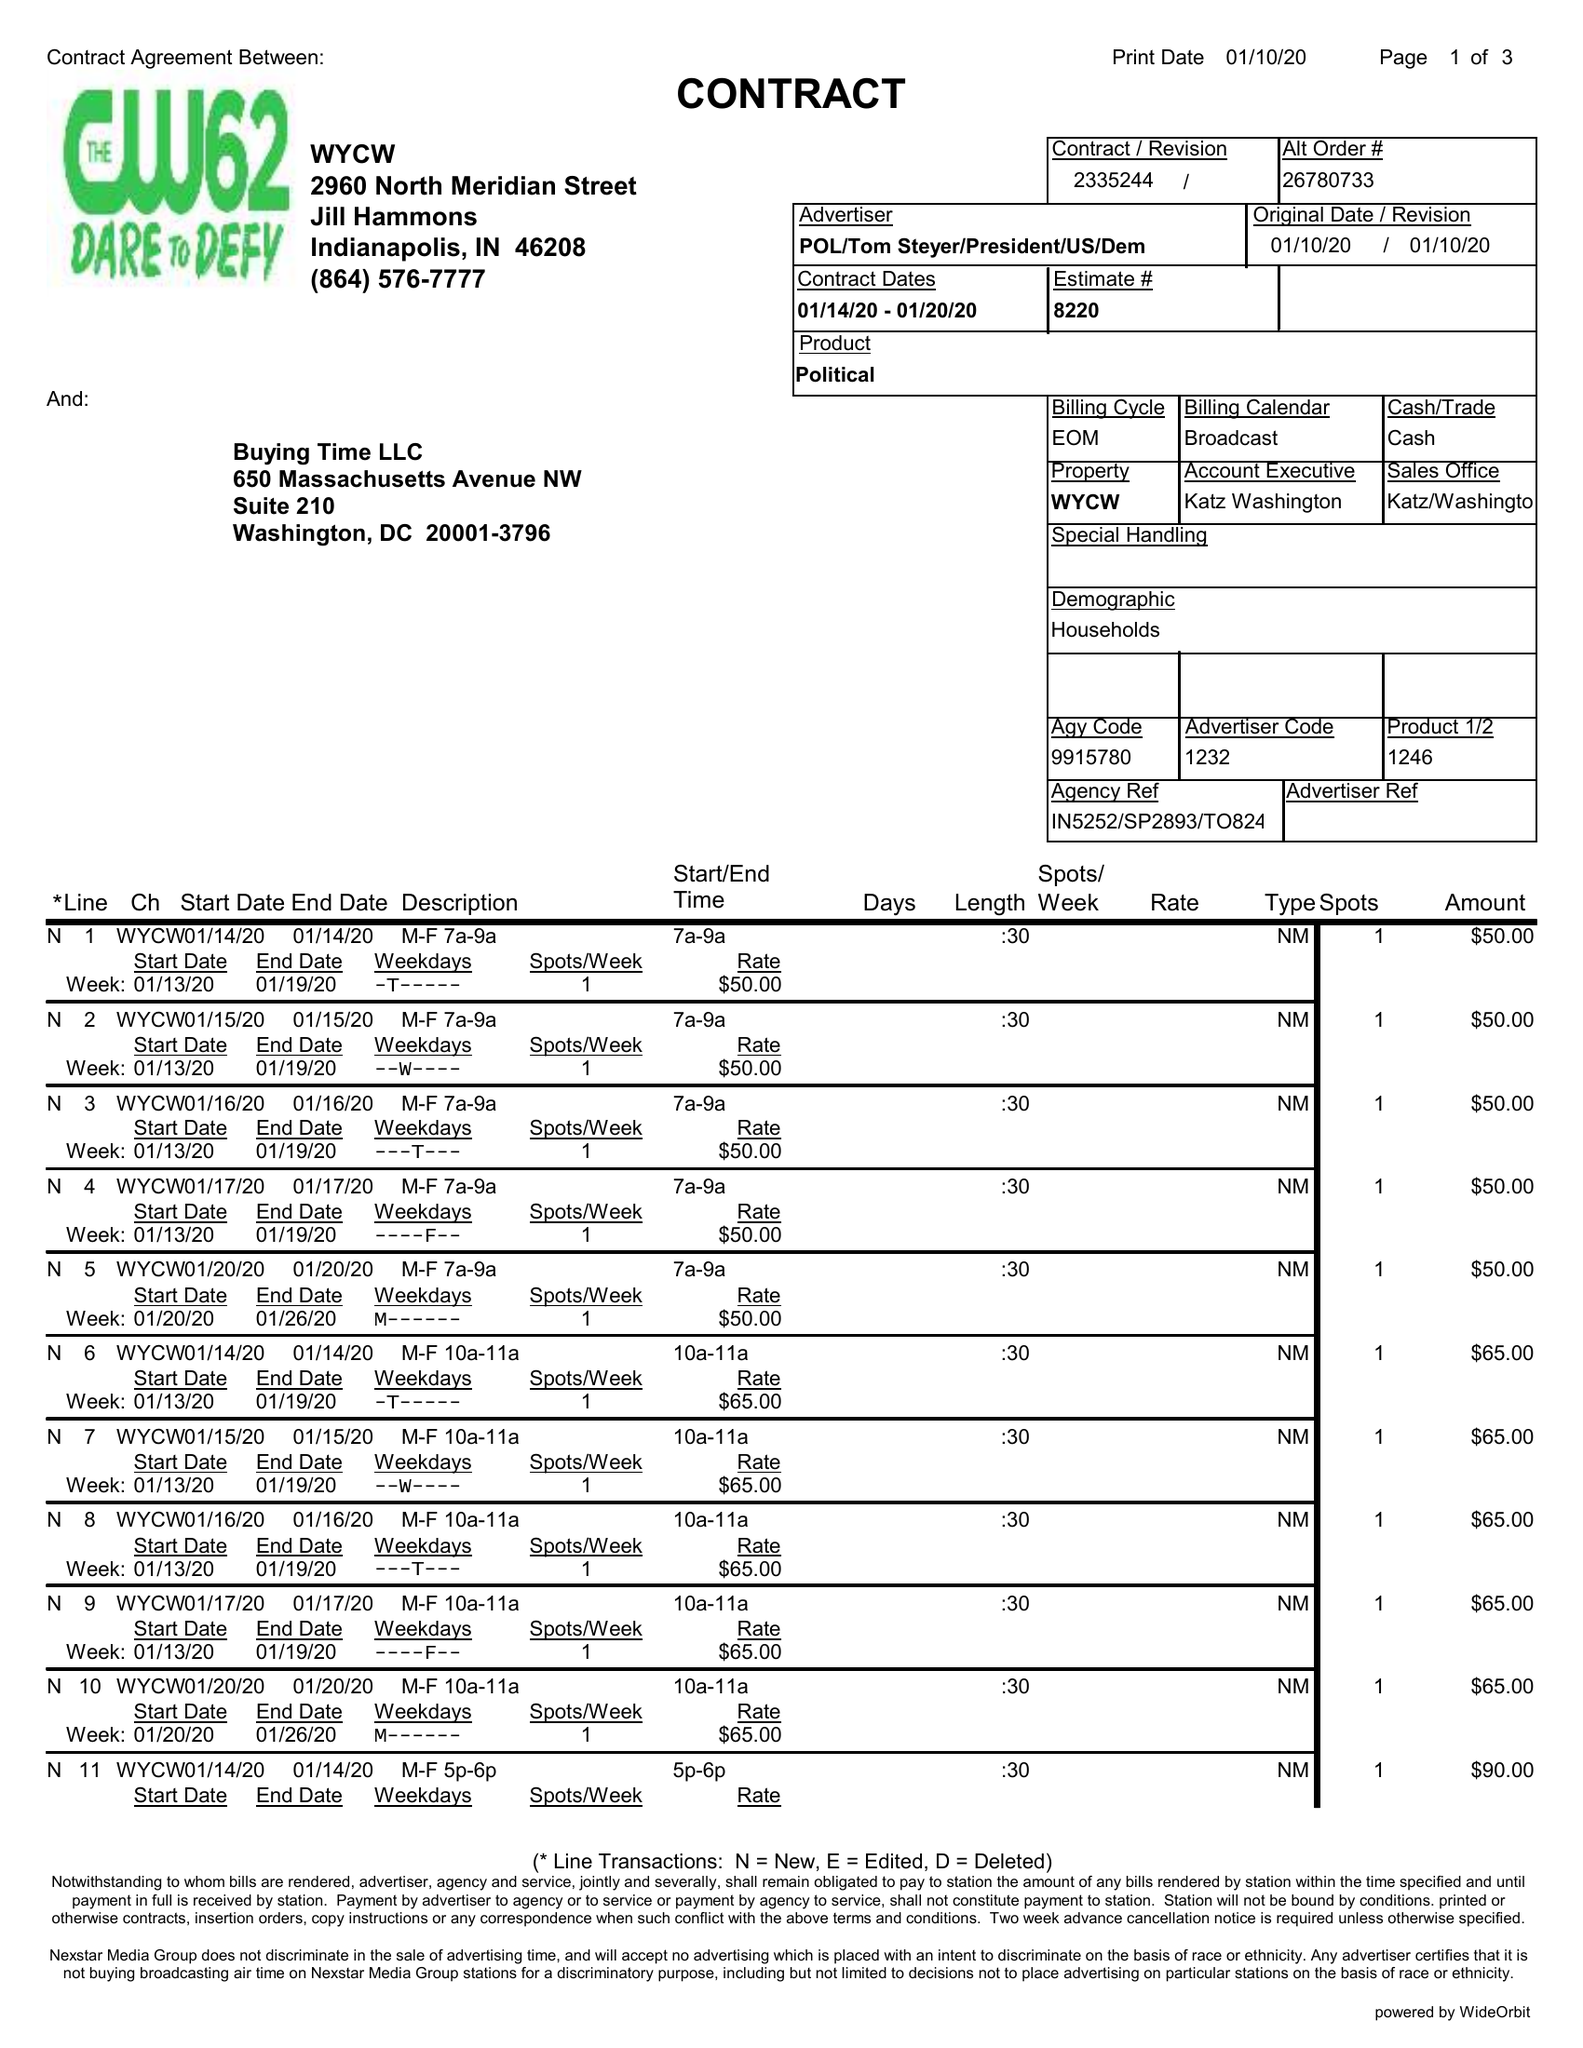What is the value for the flight_to?
Answer the question using a single word or phrase. 01/20/20 